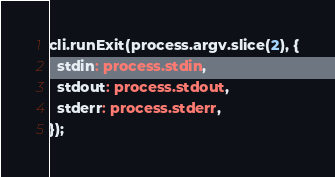Convert code to text. <code><loc_0><loc_0><loc_500><loc_500><_TypeScript_>cli.runExit(process.argv.slice(2), {
  stdin: process.stdin,
  stdout: process.stdout,
  stderr: process.stderr,
});
</code> 